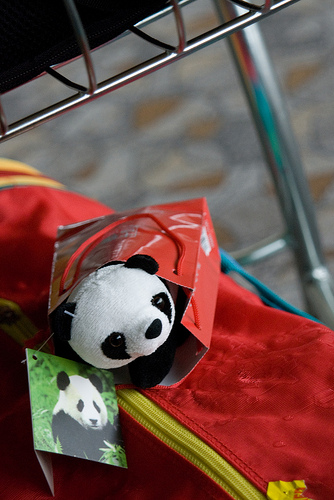<image>
Is the panda in the bag? Yes. The panda is contained within or inside the bag, showing a containment relationship. Is the panda toy on the gym bag? Yes. Looking at the image, I can see the panda toy is positioned on top of the gym bag, with the gym bag providing support. 